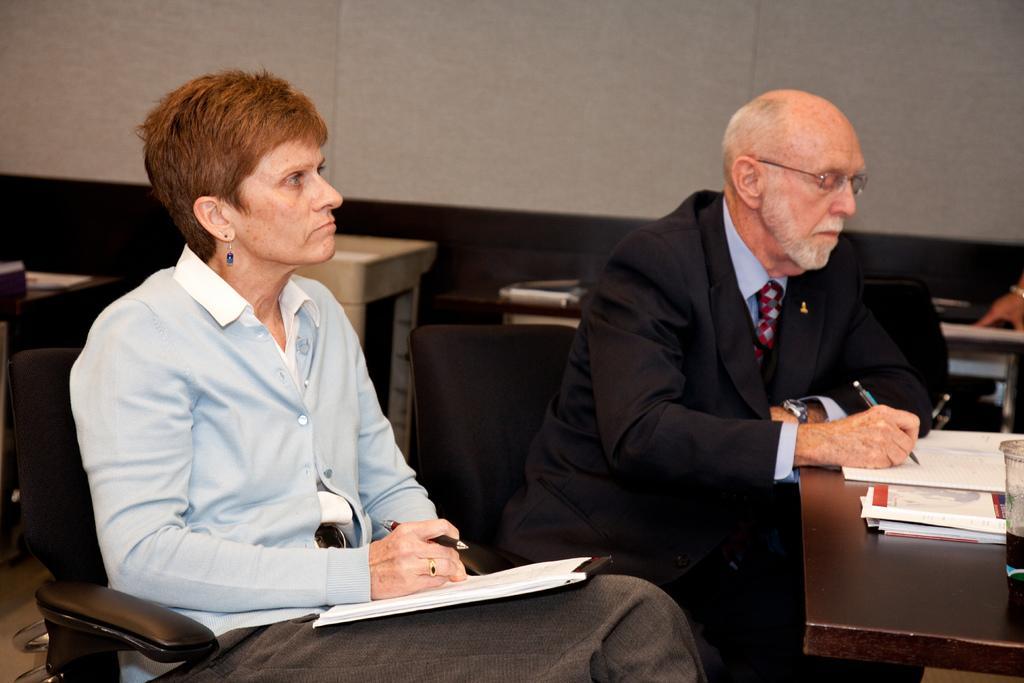In one or two sentences, can you explain what this image depicts? on the background we can see a wall. Here we can see two persons sitting on the chairs in front of a table by holding papers and pen in their hands. Here on the table we can see glass and books. 